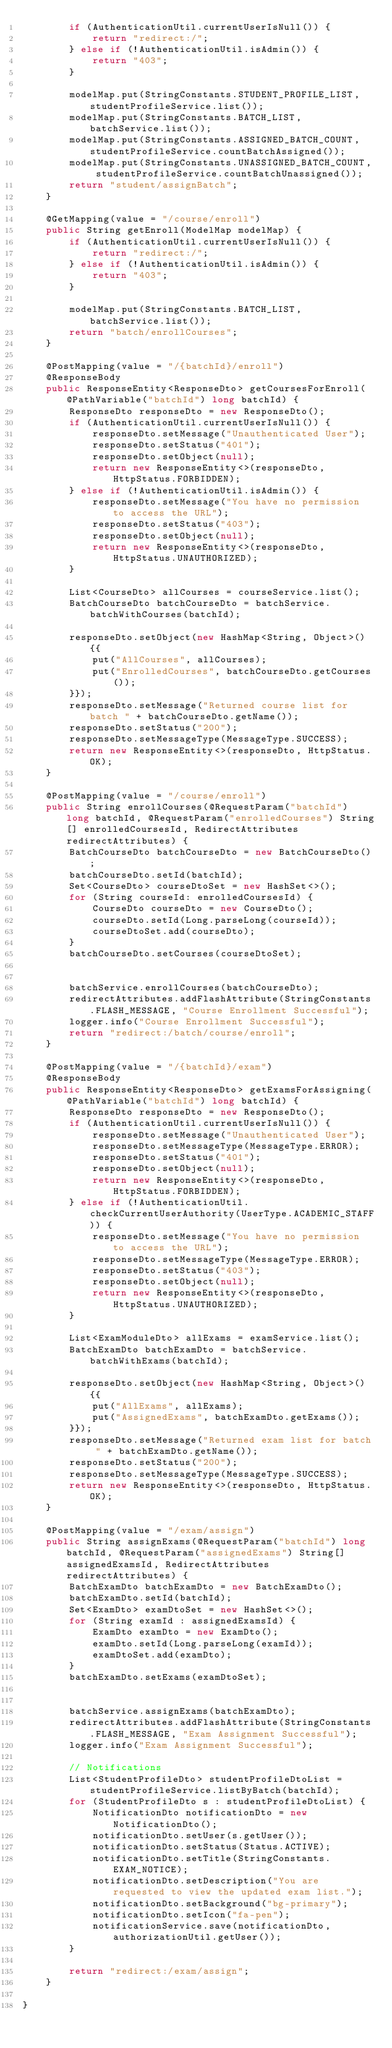Convert code to text. <code><loc_0><loc_0><loc_500><loc_500><_Java_>        if (AuthenticationUtil.currentUserIsNull()) {
            return "redirect:/";
        } else if (!AuthenticationUtil.isAdmin()) {
            return "403";
        }

        modelMap.put(StringConstants.STUDENT_PROFILE_LIST, studentProfileService.list());
        modelMap.put(StringConstants.BATCH_LIST, batchService.list());
        modelMap.put(StringConstants.ASSIGNED_BATCH_COUNT, studentProfileService.countBatchAssigned());
        modelMap.put(StringConstants.UNASSIGNED_BATCH_COUNT, studentProfileService.countBatchUnassigned());
        return "student/assignBatch";
    }

    @GetMapping(value = "/course/enroll")
    public String getEnroll(ModelMap modelMap) {
        if (AuthenticationUtil.currentUserIsNull()) {
            return "redirect:/";
        } else if (!AuthenticationUtil.isAdmin()) {
            return "403";
        }

        modelMap.put(StringConstants.BATCH_LIST, batchService.list());
        return "batch/enrollCourses";
    }

    @PostMapping(value = "/{batchId}/enroll")
    @ResponseBody
    public ResponseEntity<ResponseDto> getCoursesForEnroll(@PathVariable("batchId") long batchId) {
        ResponseDto responseDto = new ResponseDto();
        if (AuthenticationUtil.currentUserIsNull()) {
            responseDto.setMessage("Unauthenticated User");
            responseDto.setStatus("401");
            responseDto.setObject(null);
            return new ResponseEntity<>(responseDto, HttpStatus.FORBIDDEN);
        } else if (!AuthenticationUtil.isAdmin()) {
            responseDto.setMessage("You have no permission to access the URL");
            responseDto.setStatus("403");
            responseDto.setObject(null);
            return new ResponseEntity<>(responseDto, HttpStatus.UNAUTHORIZED);
        }

        List<CourseDto> allCourses = courseService.list();
        BatchCourseDto batchCourseDto = batchService.batchWithCourses(batchId);

        responseDto.setObject(new HashMap<String, Object>(){{
            put("AllCourses", allCourses);
            put("EnrolledCourses", batchCourseDto.getCourses());
        }});
        responseDto.setMessage("Returned course list for batch " + batchCourseDto.getName());
        responseDto.setStatus("200");
        responseDto.setMessageType(MessageType.SUCCESS);
        return new ResponseEntity<>(responseDto, HttpStatus.OK);
    }

    @PostMapping(value = "/course/enroll")
    public String enrollCourses(@RequestParam("batchId") long batchId, @RequestParam("enrolledCourses") String[] enrolledCoursesId, RedirectAttributes redirectAttributes) {
        BatchCourseDto batchCourseDto = new BatchCourseDto();
        batchCourseDto.setId(batchId);
        Set<CourseDto> courseDtoSet = new HashSet<>();
        for (String courseId: enrolledCoursesId) {
            CourseDto courseDto = new CourseDto();
            courseDto.setId(Long.parseLong(courseId));
            courseDtoSet.add(courseDto);
        }
        batchCourseDto.setCourses(courseDtoSet);


        batchService.enrollCourses(batchCourseDto);
        redirectAttributes.addFlashAttribute(StringConstants.FLASH_MESSAGE, "Course Enrollment Successful");
        logger.info("Course Enrollment Successful");
        return "redirect:/batch/course/enroll";
    }

    @PostMapping(value = "/{batchId}/exam")
    @ResponseBody
    public ResponseEntity<ResponseDto> getExamsForAssigning(@PathVariable("batchId") long batchId) {
        ResponseDto responseDto = new ResponseDto();
        if (AuthenticationUtil.currentUserIsNull()) {
            responseDto.setMessage("Unauthenticated User");
            responseDto.setMessageType(MessageType.ERROR);
            responseDto.setStatus("401");
            responseDto.setObject(null);
            return new ResponseEntity<>(responseDto, HttpStatus.FORBIDDEN);
        } else if (!AuthenticationUtil.checkCurrentUserAuthority(UserType.ACADEMIC_STAFF)) {
            responseDto.setMessage("You have no permission to access the URL");
            responseDto.setMessageType(MessageType.ERROR);
            responseDto.setStatus("403");
            responseDto.setObject(null);
            return new ResponseEntity<>(responseDto, HttpStatus.UNAUTHORIZED);
        }

        List<ExamModuleDto> allExams = examService.list();
        BatchExamDto batchExamDto = batchService.batchWithExams(batchId);

        responseDto.setObject(new HashMap<String, Object>() {{
            put("AllExams", allExams);
            put("AssignedExams", batchExamDto.getExams());
        }});
        responseDto.setMessage("Returned exam list for batch " + batchExamDto.getName());
        responseDto.setStatus("200");
        responseDto.setMessageType(MessageType.SUCCESS);
        return new ResponseEntity<>(responseDto, HttpStatus.OK);
    }

    @PostMapping(value = "/exam/assign")
    public String assignExams(@RequestParam("batchId") long batchId, @RequestParam("assignedExams") String[] assignedExamsId, RedirectAttributes redirectAttributes) {
        BatchExamDto batchExamDto = new BatchExamDto();
        batchExamDto.setId(batchId);
        Set<ExamDto> examDtoSet = new HashSet<>();
        for (String examId : assignedExamsId) {
            ExamDto examDto = new ExamDto();
            examDto.setId(Long.parseLong(examId));
            examDtoSet.add(examDto);
        }
        batchExamDto.setExams(examDtoSet);


        batchService.assignExams(batchExamDto);
        redirectAttributes.addFlashAttribute(StringConstants.FLASH_MESSAGE, "Exam Assignment Successful");
        logger.info("Exam Assignment Successful");

        // Notifications
        List<StudentProfileDto> studentProfileDtoList = studentProfileService.listByBatch(batchId);
        for (StudentProfileDto s : studentProfileDtoList) {
            NotificationDto notificationDto = new NotificationDto();
            notificationDto.setUser(s.getUser());
            notificationDto.setStatus(Status.ACTIVE);
            notificationDto.setTitle(StringConstants.EXAM_NOTICE);
            notificationDto.setDescription("You are requested to view the updated exam list.");
            notificationDto.setBackground("bg-primary");
            notificationDto.setIcon("fa-pen");
            notificationService.save(notificationDto, authorizationUtil.getUser());
        }

        return "redirect:/exam/assign";
    }

}
</code> 